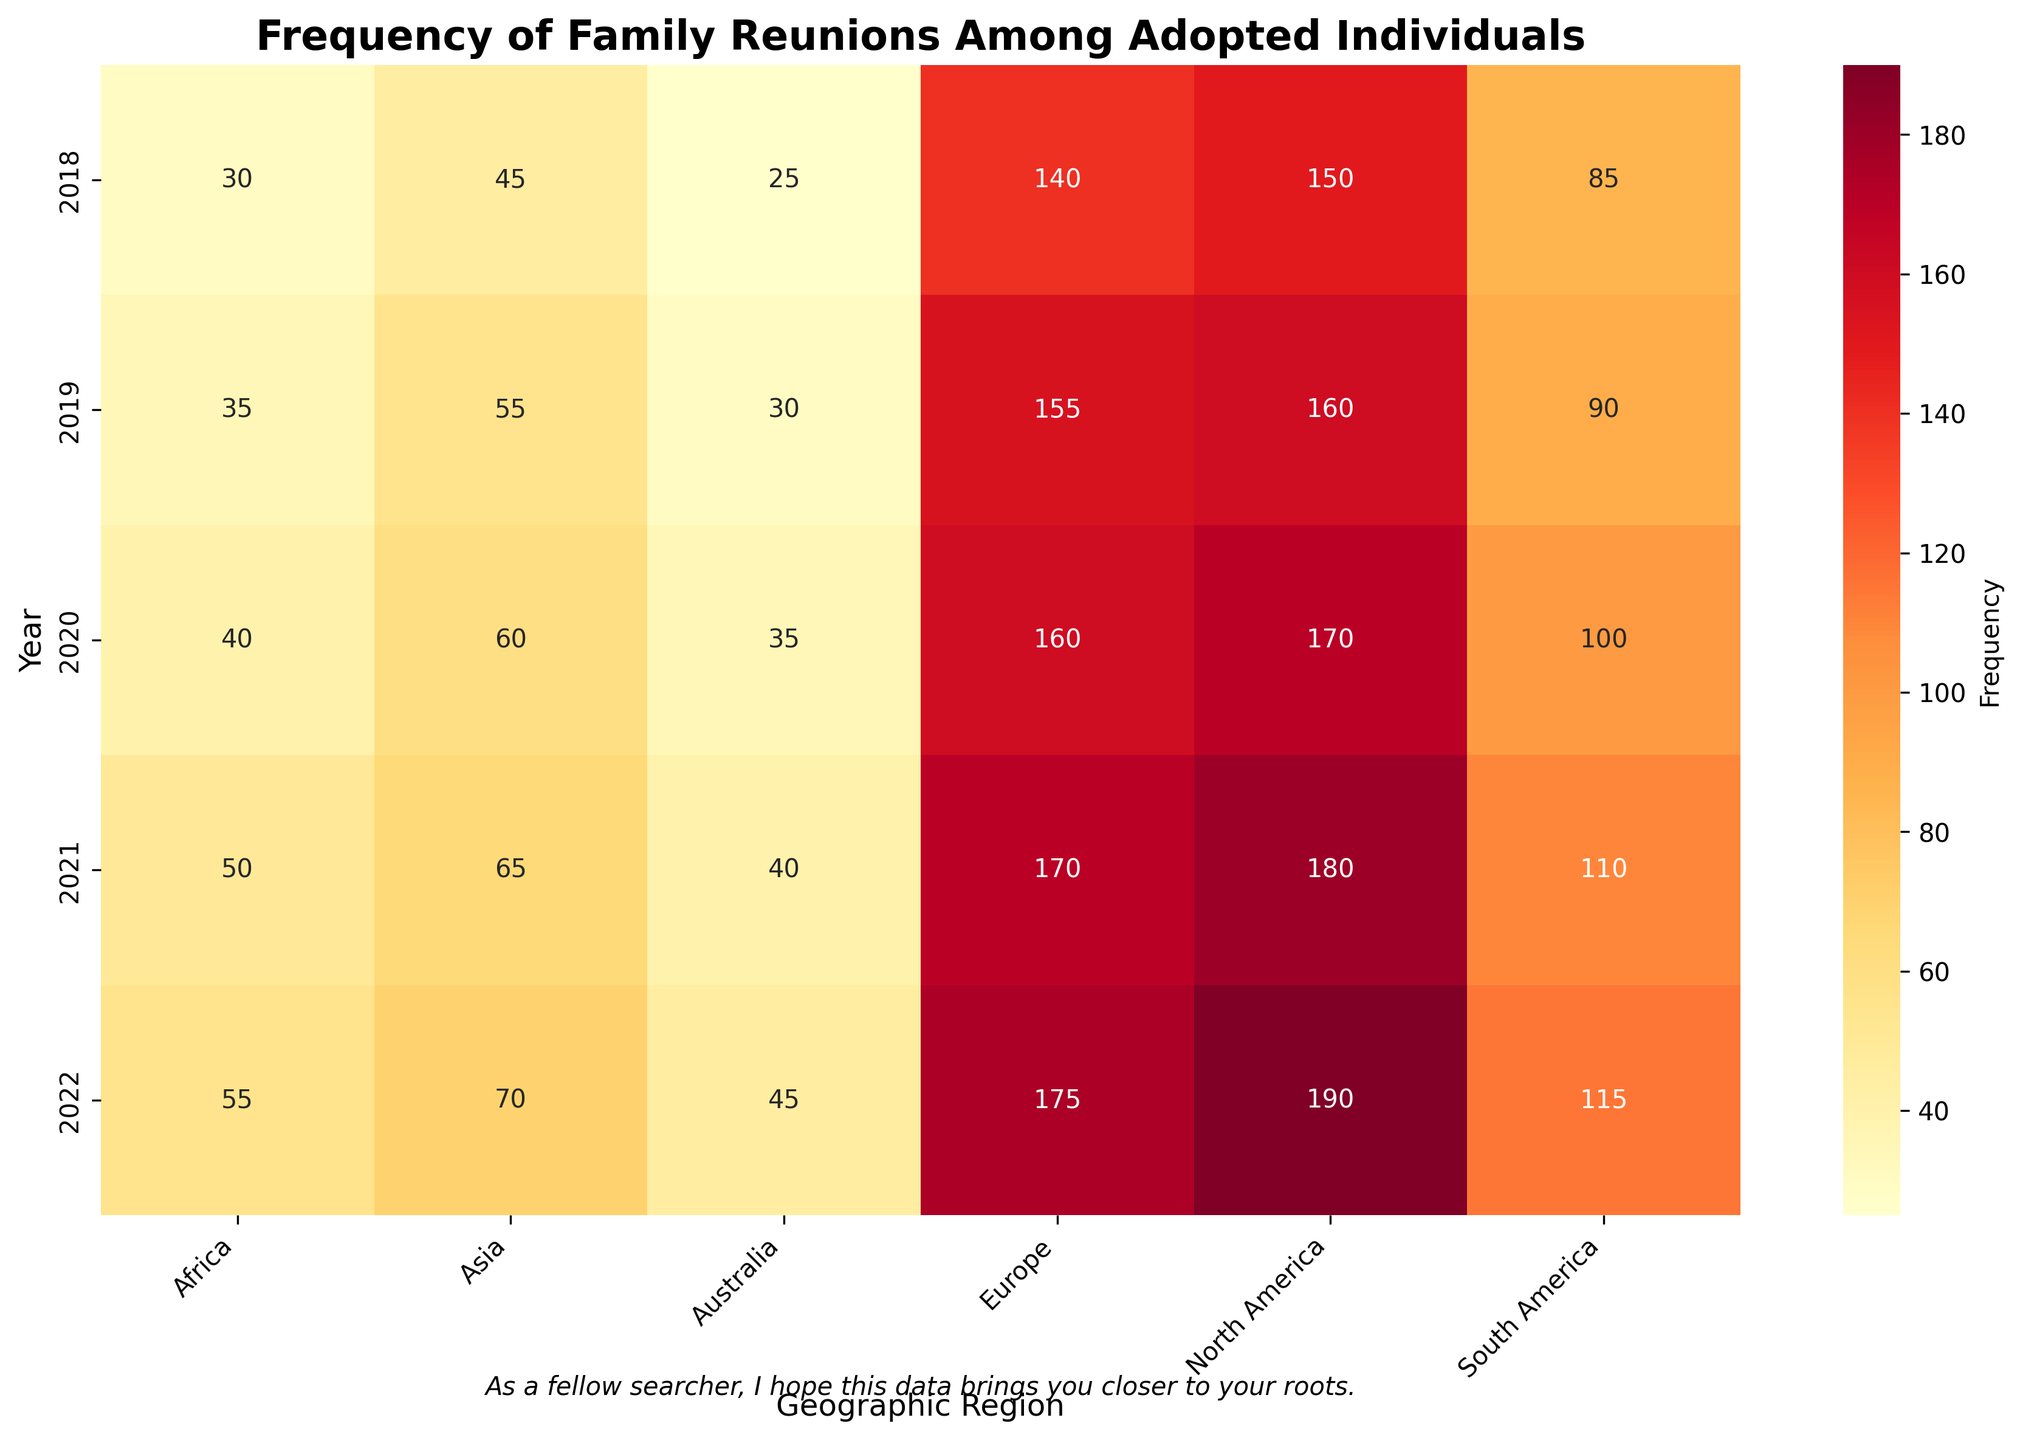What is the title of the heatmap? The title is usually located at the top of the heatmap, indicating what the plot is about. It helps to understand the context of the data displayed.
Answer: Frequency of Family Reunions Among Adopted Individuals Which year shows the highest frequency of family reunions in Europe? By looking at the cells corresponding to Europe and identifying the maximum value, we can determine the year with the highest frequency.
Answer: 2022 What is the range of frequencies in North America over the years? We need to identify the minimum and maximum frequencies for North America by checking the corresponding cells.
Answer: 150 to 190 What is the average frequency of family reunions in Asia from 2018 to 2022? Calculate the sum of frequencies for Asia over the years and divide by the number of years. (45 + 55 + 60 + 65 + 70) / 5 = 59
Answer: 59 Which geographic region had the lowest frequency of family reunions in 2020? Locate the year 2020 and identify the region with the smallest frequency value in that row.
Answer: Australia Did the frequency of family reunions in South America increase or decrease from 2018 to 2022? Compare the frequency values for South America in 2018 and 2022. (85 in 2018 and 115 in 2022)
Answer: Increase Which geographic region shows a consistent increase in frequencies from 2018 to 2022? For a consistent increase, each year's frequency should be higher than the previous year's. We need to check each region's yearly data.
Answer: North America What region had the closest frequency values in 2021 and 2022? Calculate the differences between 2021 and 2022 frequencies for each region and identify the smallest difference.
Answer: Europe (175 in 2022 - 170 in 2021 = 5) Which year had the largest total frequency of family reunions across all geographic regions? Sum the frequencies for each year across all regions and compare these totals.
Answer: 2022 